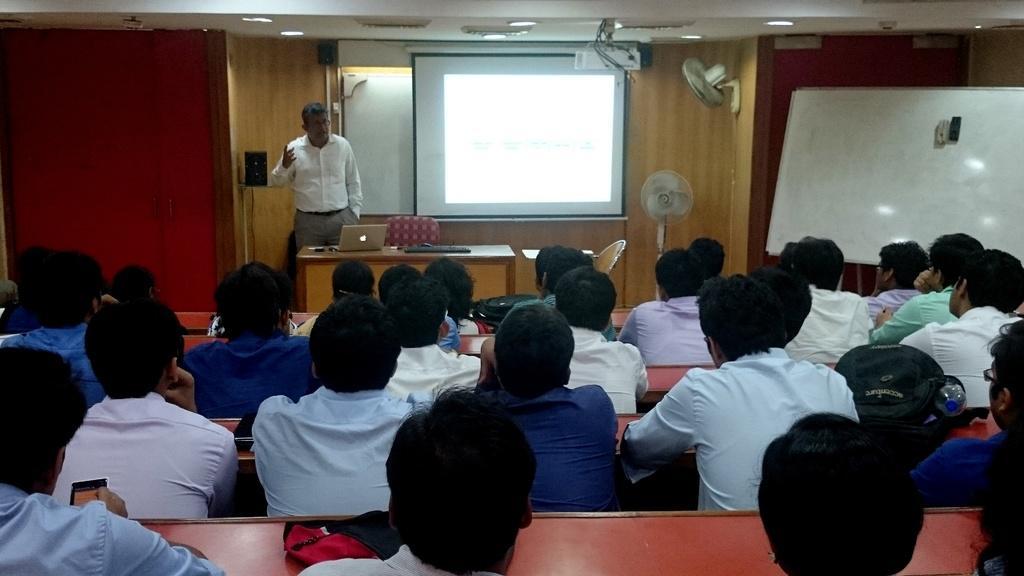In one or two sentences, can you explain what this image depicts? In this picture I can see the inside view of a room, where I can see number of men sitting on benches and I can see the white board on the right side of this image. In the middle of this picture I can see the projector screen and a man standing and in front of him I can see a table, on which there is a laptop and beside to him, I can see 2 chairs and I can also see 2 fans. On the top of this picture I can see the lights on the ceiling. 